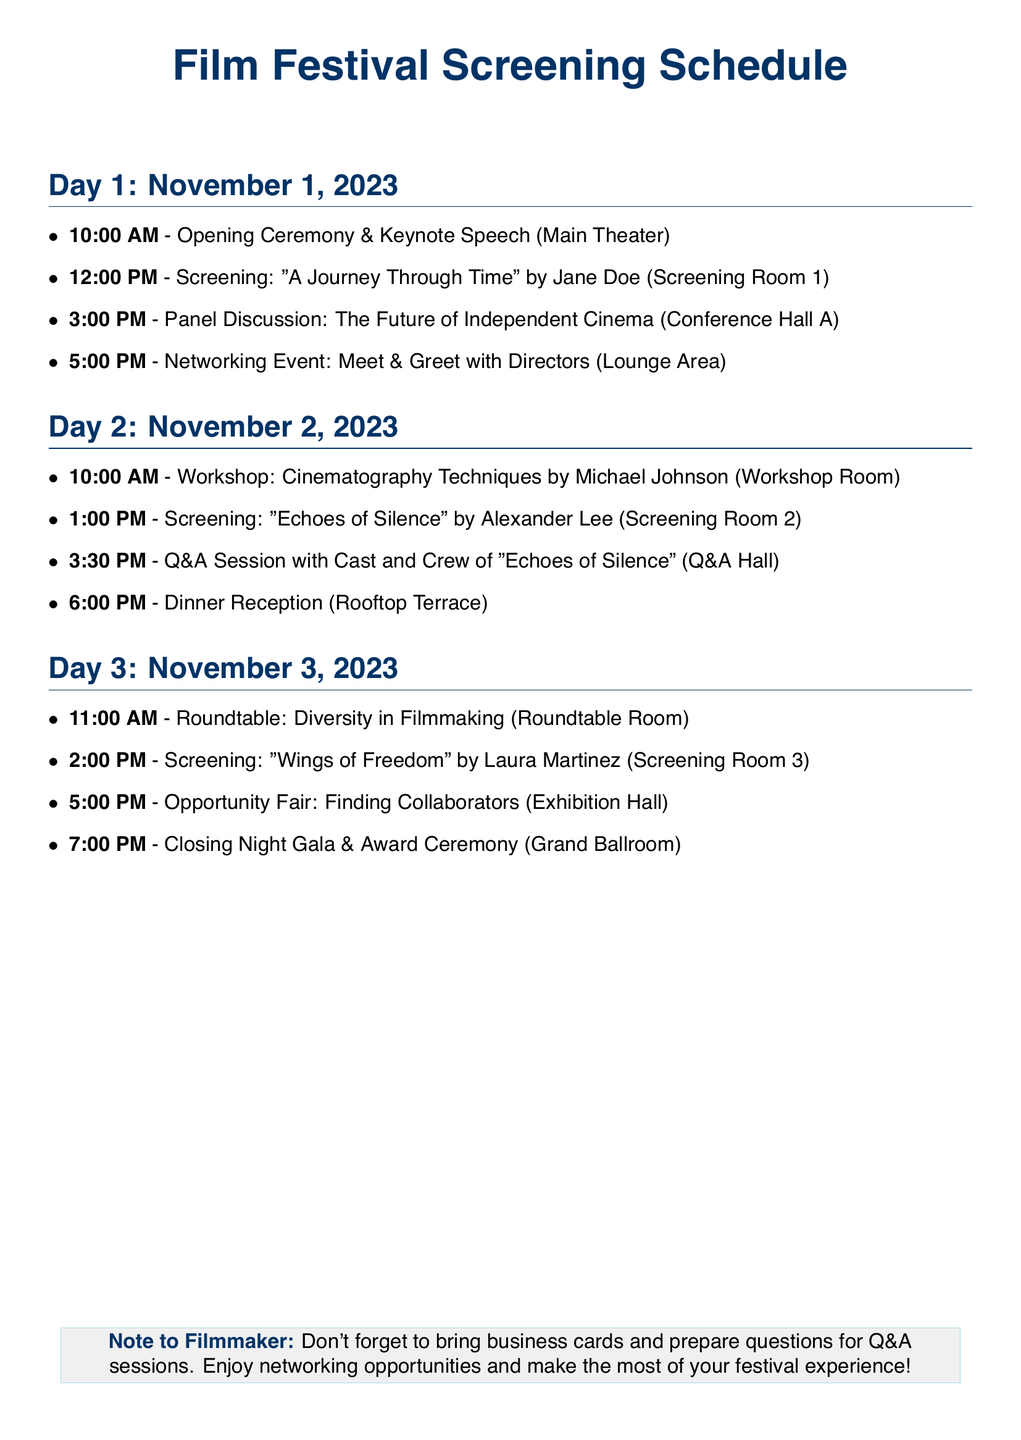what is the date of the opening ceremony? The date of the opening ceremony is mentioned in the itinerary as Day 1, which is November 1, 2023.
Answer: November 1, 2023 who is the director of "A Journey Through Time"? The director of the film "A Journey Through Time," as indicated in the schedule, is Jane Doe.
Answer: Jane Doe what time does the dinner reception start? The dinner reception's start time is explicitly provided in the document under Day 2.
Answer: 6:00 PM how many panel discussions are scheduled? The document lists one panel discussion on Day 1 and one roundtable on Day 3, collectively making it two discussion events.
Answer: 2 which event follows the screening of "Echoes of Silence"? The event that follows the screening of "Echoes of Silence" is the Q&A Session with the cast and crew.
Answer: Q&A Session what location hosts the closing night gala? The closing night gala is hosted in the Grand Ballroom, as specified in the itinerary.
Answer: Grand Ballroom is there a workshop on cinematography techniques? Yes, a workshop on cinematography techniques is scheduled on Day 2 of the festival.
Answer: Yes what is the main focus of the roundtable scheduled on Day 3? The main focus of the roundtable scheduled on Day 3 is diversity in filmmaking, as stated in the document.
Answer: Diversity in Filmmaking 